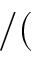Convert formula to latex. <formula><loc_0><loc_0><loc_500><loc_500>/ (</formula> 